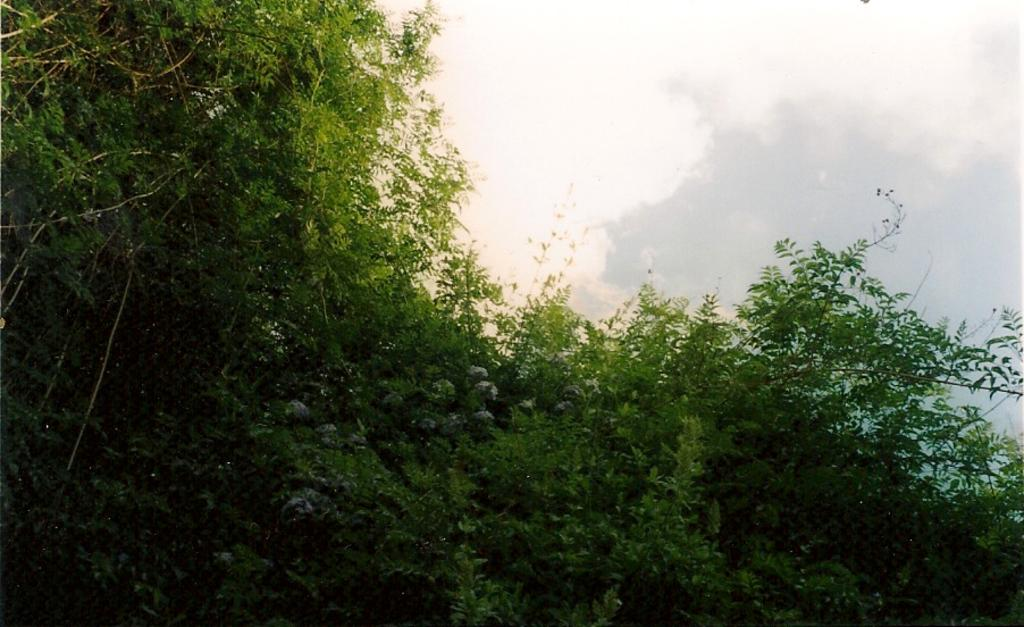What type of vegetation can be seen in the image? There are trees in the image. What is visible in the background of the image? The sky is visible in the image. What is the value of the mist in the image? There is no mist present in the image, so it is not possible to determine its value. 